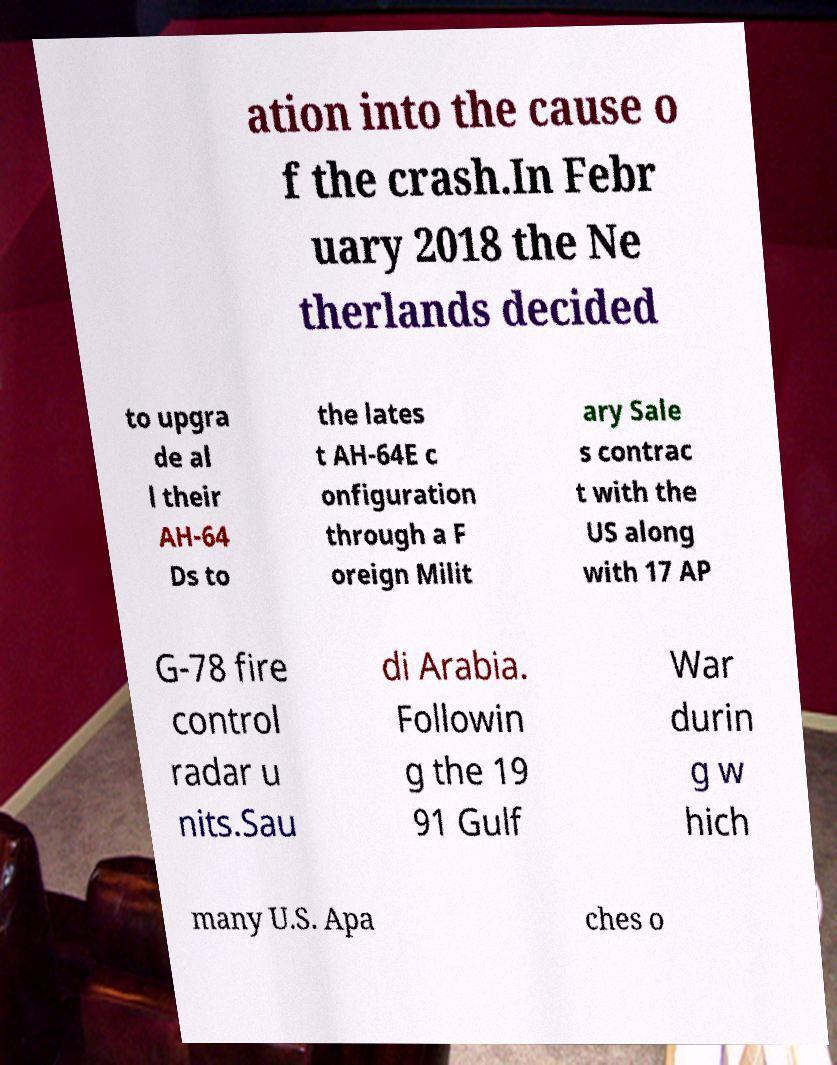Can you read and provide the text displayed in the image?This photo seems to have some interesting text. Can you extract and type it out for me? ation into the cause o f the crash.In Febr uary 2018 the Ne therlands decided to upgra de al l their AH-64 Ds to the lates t AH-64E c onfiguration through a F oreign Milit ary Sale s contrac t with the US along with 17 AP G-78 fire control radar u nits.Sau di Arabia. Followin g the 19 91 Gulf War durin g w hich many U.S. Apa ches o 